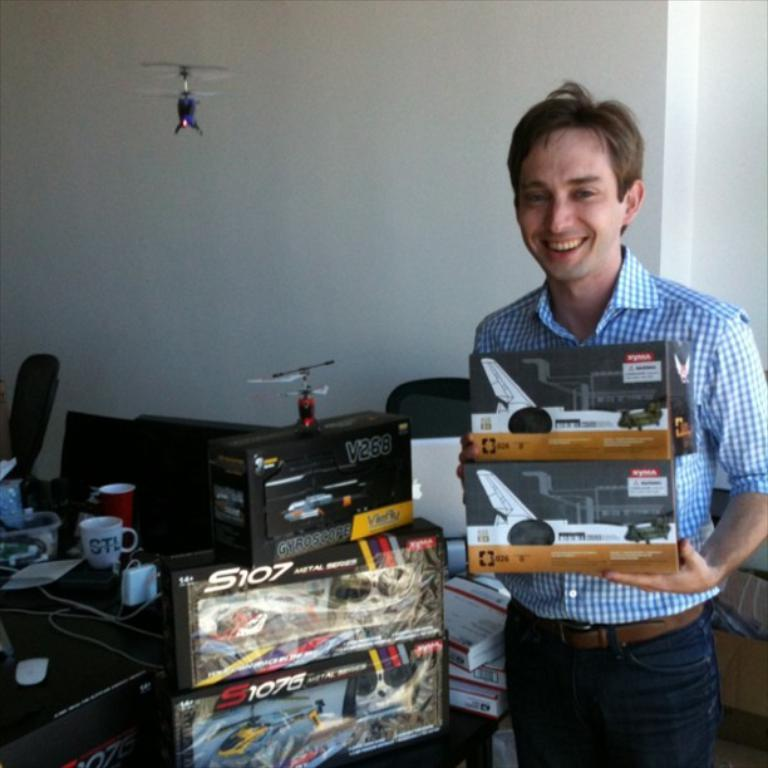<image>
Present a compact description of the photo's key features. a man next to two boxs of S107 toy planes 